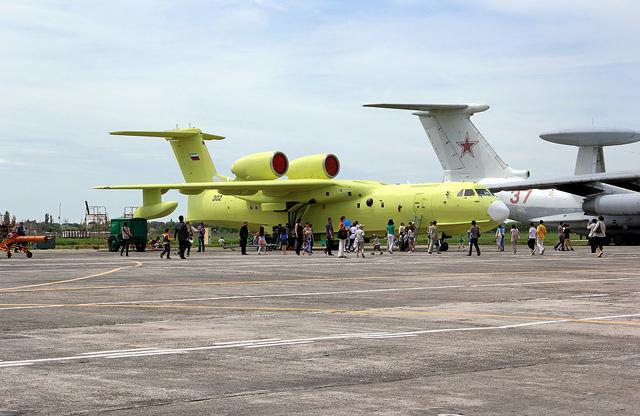How many planes are visible?
Quick response, please. 2. IS this a private plane?
Quick response, please. No. Are the planes in flight?
Answer briefly. No. Are the people boarding the planes?
Be succinct. Yes. 